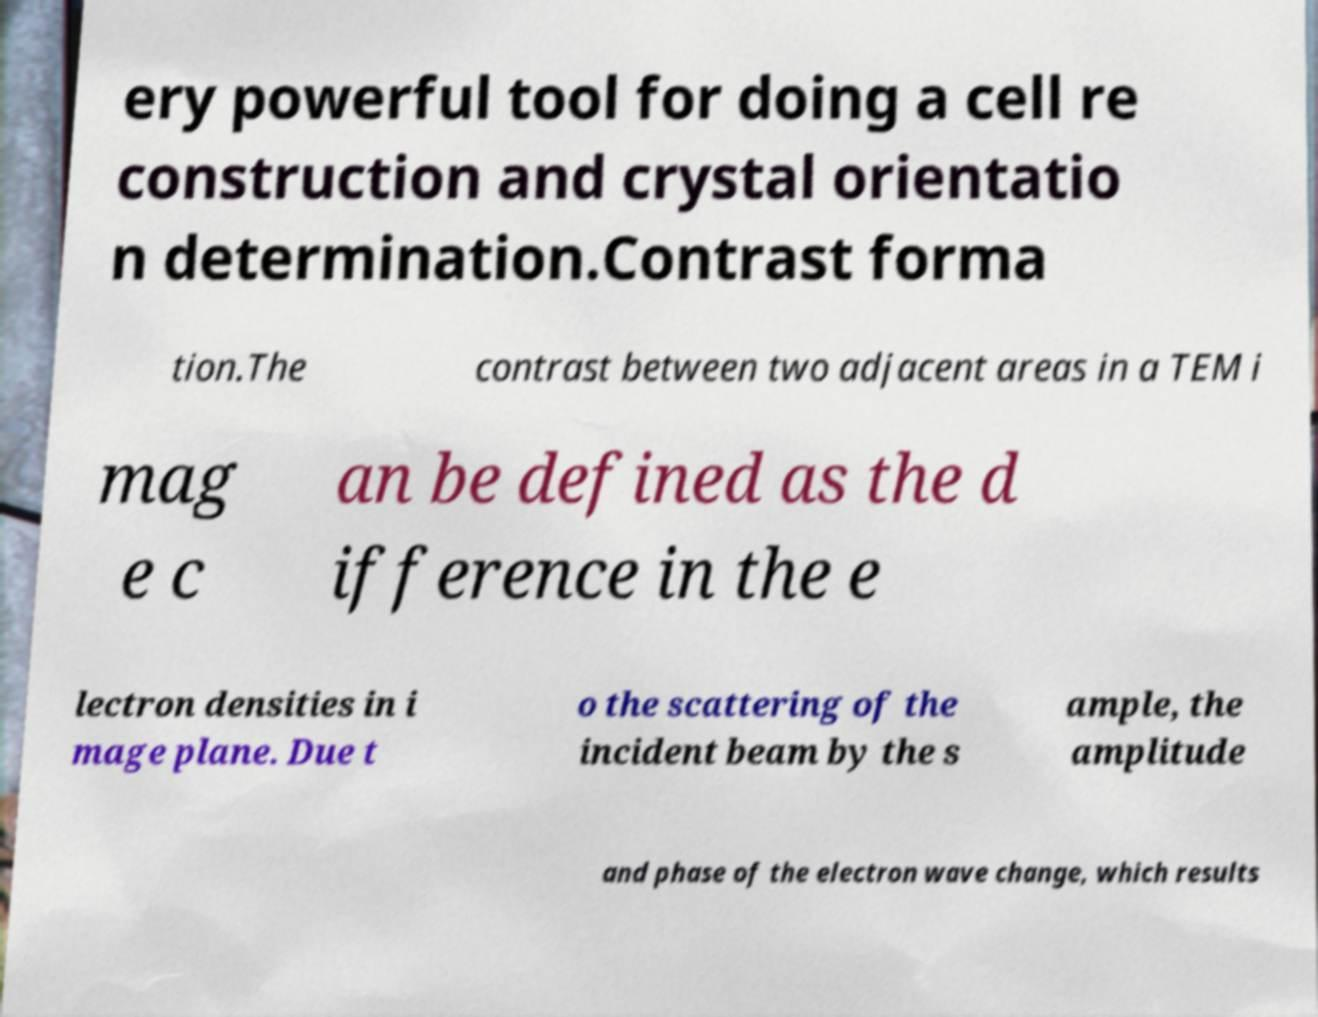There's text embedded in this image that I need extracted. Can you transcribe it verbatim? ery powerful tool for doing a cell re construction and crystal orientatio n determination.Contrast forma tion.The contrast between two adjacent areas in a TEM i mag e c an be defined as the d ifference in the e lectron densities in i mage plane. Due t o the scattering of the incident beam by the s ample, the amplitude and phase of the electron wave change, which results 